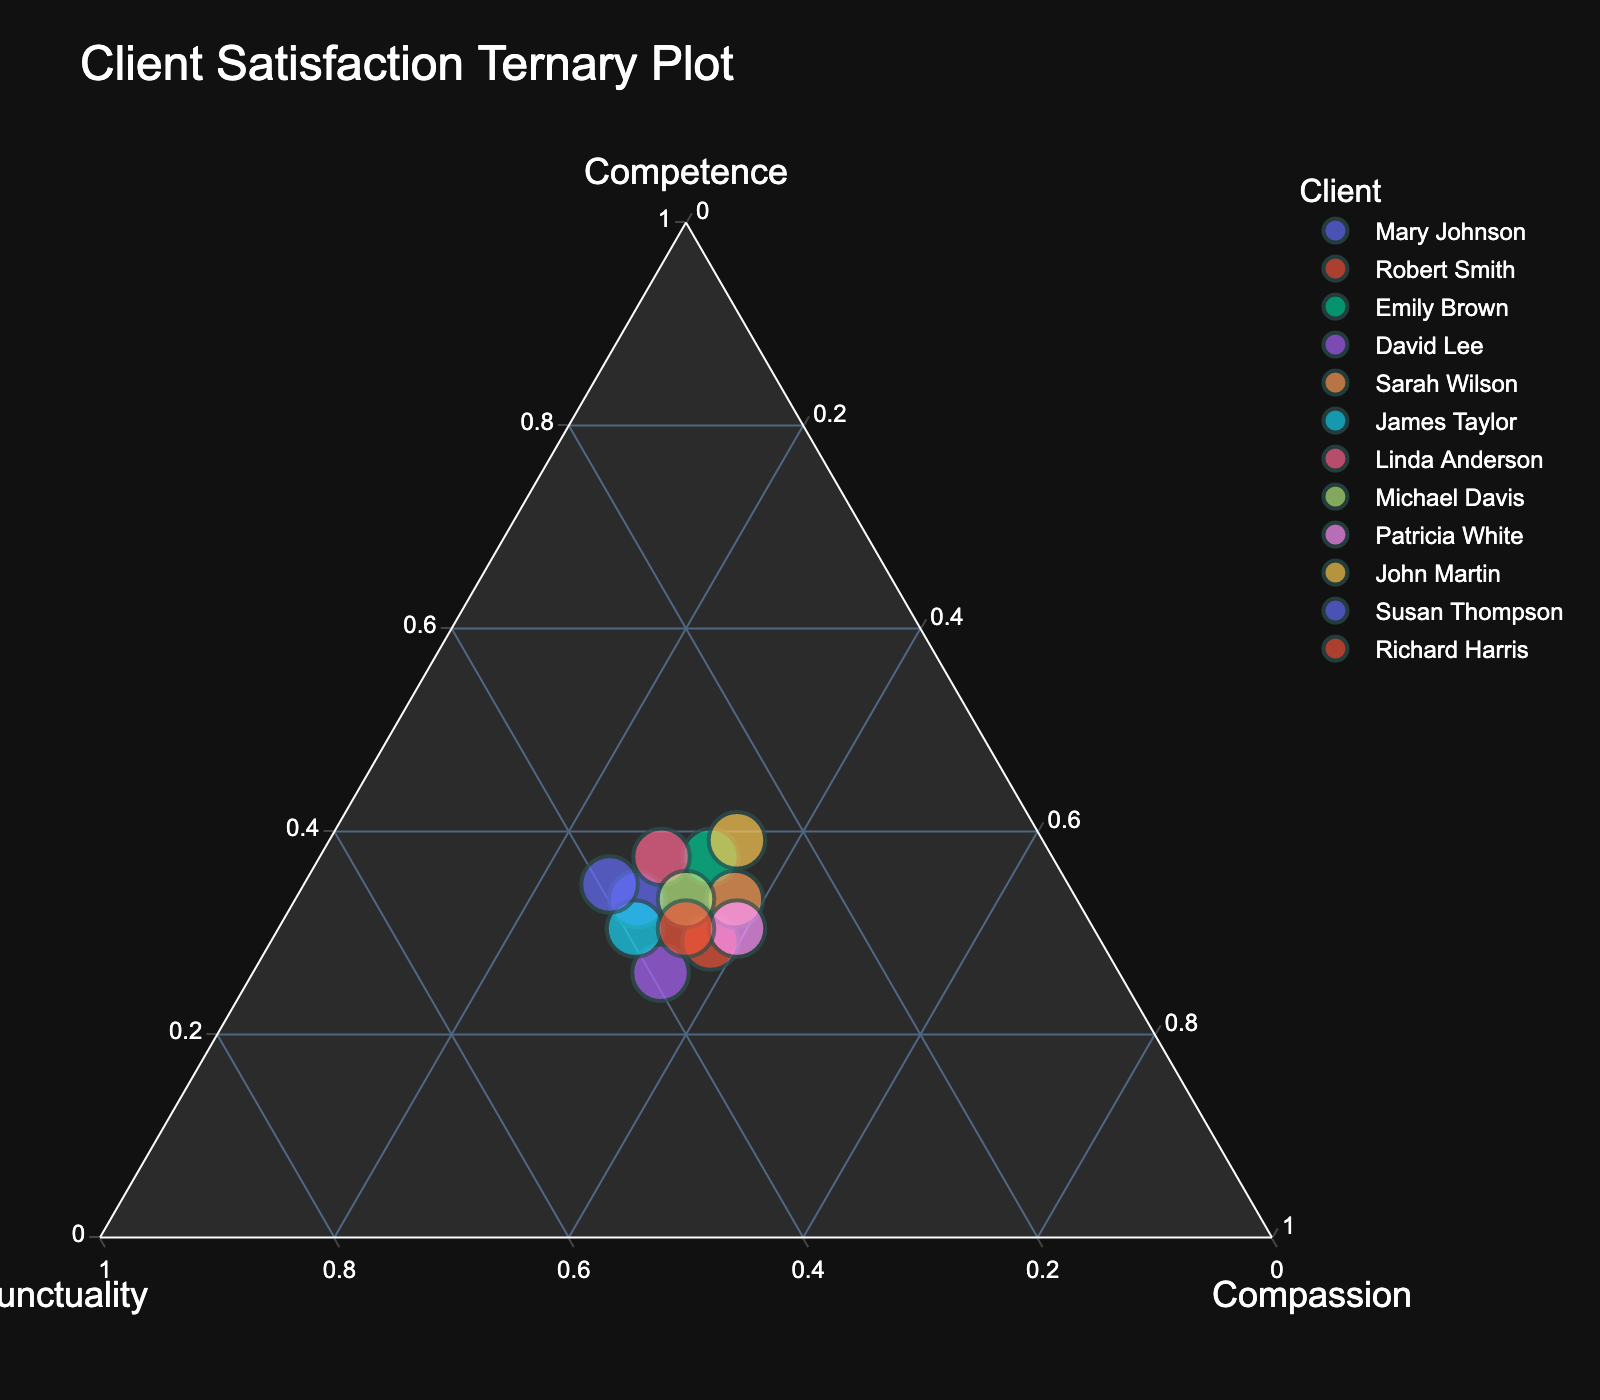Client Explanation
Answer: Concise Answer What is the title of the ternary plot? The title of the plot is displayed at the top of the figure in a larger font size.
Answer: Client Satisfaction Ternary Plot How many clients were surveyed according to the plot? Each data point represents one client, and there are data points for each client listed in the data provided.
Answer: 12 Which client has the highest competence rating? On a ternary plot, the competence rating is shown on the 'a' axis. Identify the data point that is closest to that axis.
Answer: Emily Brown Which client shows equal competence and compassion ratings? Look for the point that lies equally between the 'a' and 'c' axes.
Answer: Michael Davis Which two clients have the same punctuality rating but different compassion ratings? Find clients who share the same 'b' axis value but differ on the 'c' axis.
Answer: Mary Johnson and James Taylor What is the median competence rating for the clients? List the competence ratings, sort them, and find the middle value in the sorted list. Median of [0.6, 0.7, 0.7, 0.7, 0.7, 0.8, 0.8, 0.8, 0.8, 0.9, 0.9, 0.9] is the average of the 6th and 7th values.
Answer: 0.8 Who has the lowest compassion rating? Identify the data point closest to the 'b' and 'c' axes intersection.
Answer: Susan Thompson Which clients have compassion ratings equal to 0.8? Look for data points that lie on the line corresponding to a compassion (c) rating of 0.8.
Answer: Emily Brown, David Lee, Michael Davis, Richard Harris Which client has a better balance between competence, punctuality, and compassion? Identify the data point that is closest to the center of the ternary plot, representing a balanced score.
Answer: Michael Davis Which client is closest to having equal ratings in all three factors? Look for the point closest to the center, where all sides are equidistant, representing equal ratings.
Answer: Michael Davis 